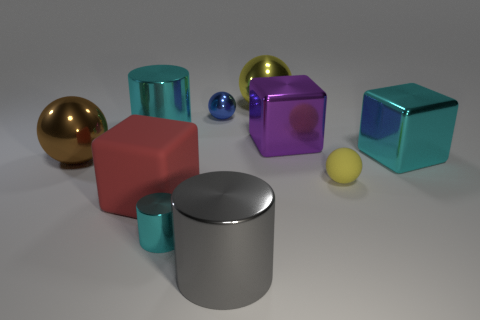How do the objects in the image interact with the light source? The objects show varied interactions with the light. You can see reflections and highlights on the smoother and shinier surfaces, like the silver cube and the brown sphere, demonstrating a strong light source. The matte objects, like the red cube, don't reflect light as much and instead have softer shadows, creating a sense of depth and textural contrast. 